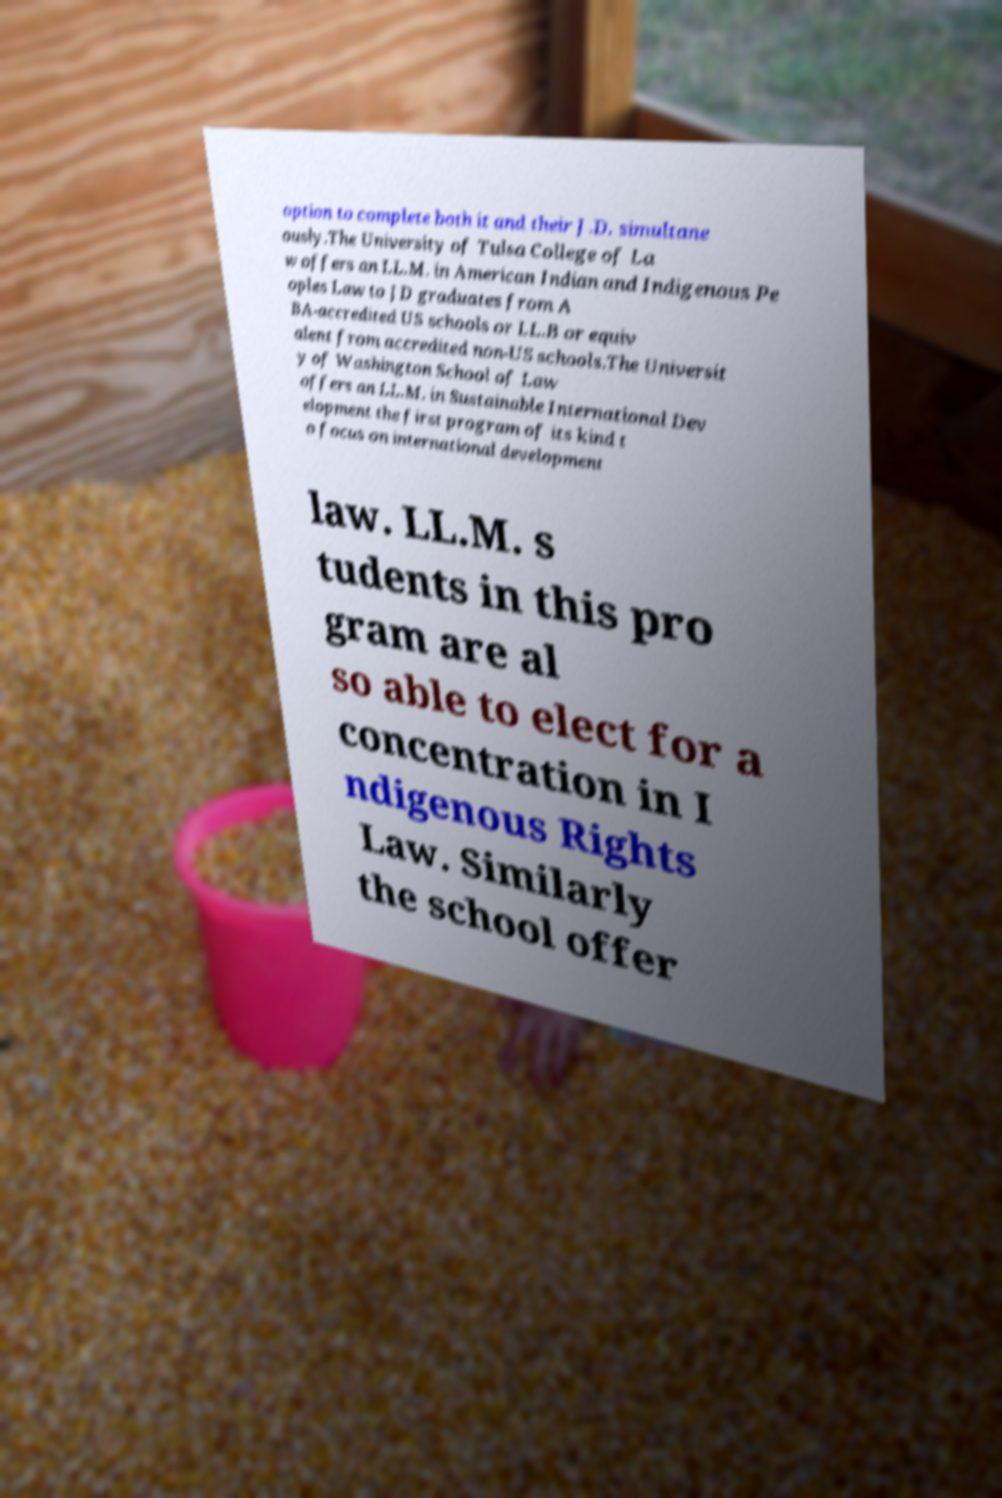Could you extract and type out the text from this image? option to complete both it and their J.D. simultane ously.The University of Tulsa College of La w offers an LL.M. in American Indian and Indigenous Pe oples Law to JD graduates from A BA-accredited US schools or LL.B or equiv alent from accredited non-US schools.The Universit y of Washington School of Law offers an LL.M. in Sustainable International Dev elopment the first program of its kind t o focus on international development law. LL.M. s tudents in this pro gram are al so able to elect for a concentration in I ndigenous Rights Law. Similarly the school offer 